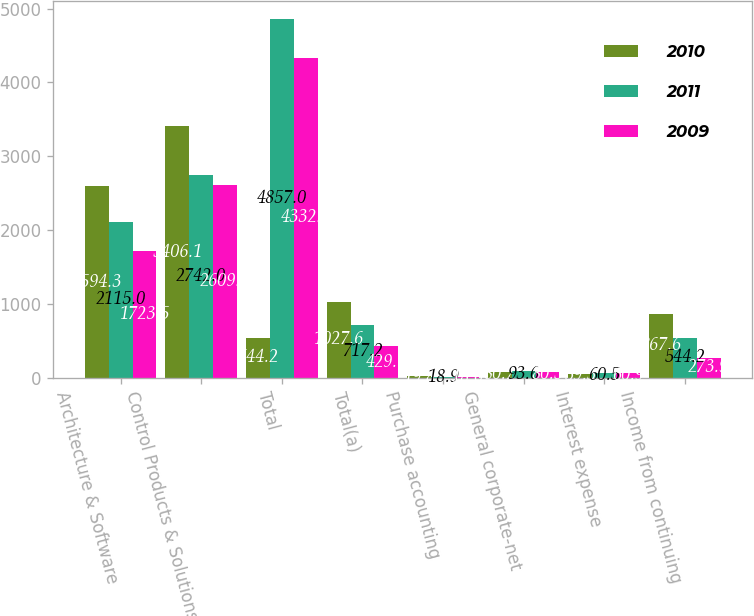<chart> <loc_0><loc_0><loc_500><loc_500><stacked_bar_chart><ecel><fcel>Architecture & Software<fcel>Control Products & Solutions<fcel>Total<fcel>Total(a)<fcel>Purchase accounting<fcel>General corporate-net<fcel>Interest expense<fcel>Income from continuing<nl><fcel>2010<fcel>2594.3<fcel>3406.1<fcel>544.2<fcel>1027.6<fcel>19.8<fcel>80.7<fcel>59.5<fcel>867.6<nl><fcel>2011<fcel>2115<fcel>2742<fcel>4857<fcel>717.2<fcel>18.9<fcel>93.6<fcel>60.5<fcel>544.2<nl><fcel>2009<fcel>1723.5<fcel>2609<fcel>4332.5<fcel>429.7<fcel>18.6<fcel>80.3<fcel>60.9<fcel>273.9<nl></chart> 